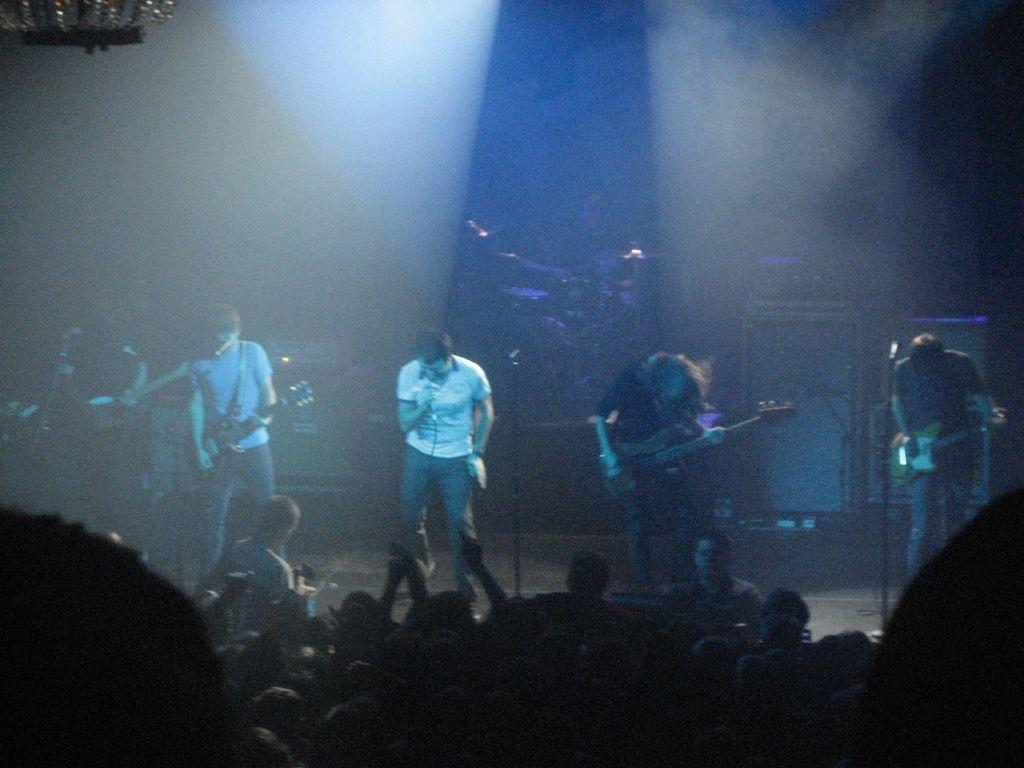What are the people in the image doing? The people in the image are playing musical instruments on a stage. Where is the stage located in the image? The stage is at the bottom of the picture. Who is watching the people on the stage? There is an audience in the picture. What is the color of the background in the image? The background of the image is dark. Can you see any clouds in the image? There are no clouds visible in the image. What type of steel is being used to construct the instruments in the image? There is no information about the materials used to construct the instruments in the image. 